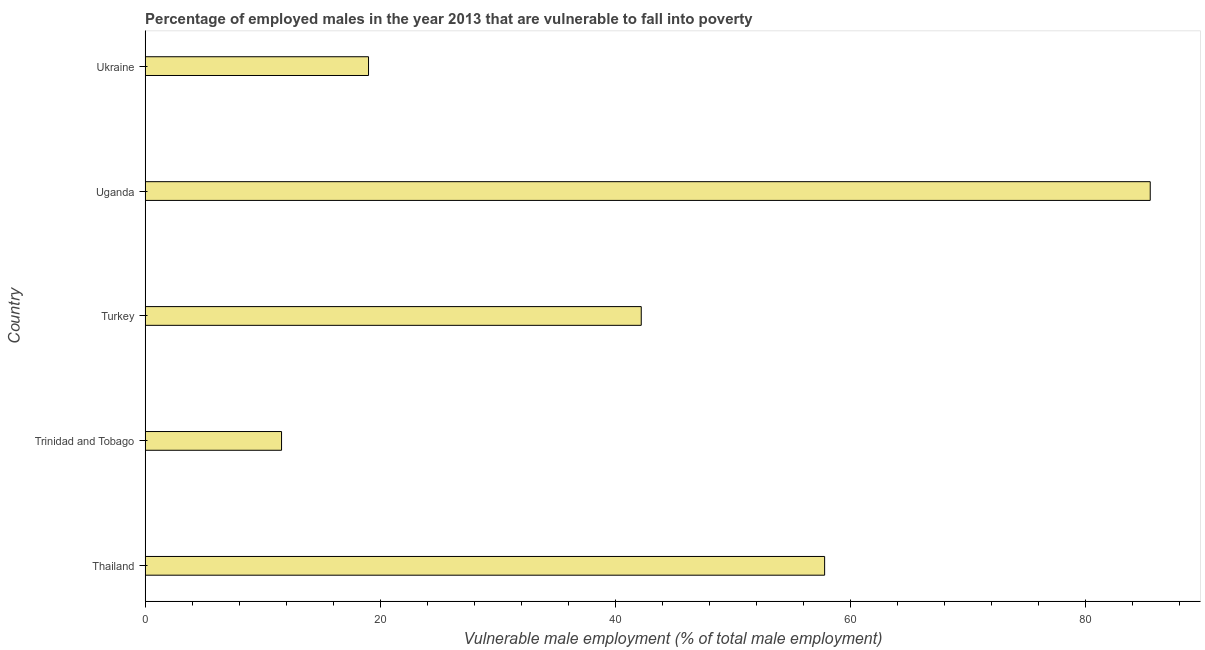Does the graph contain any zero values?
Provide a short and direct response. No. Does the graph contain grids?
Your answer should be compact. No. What is the title of the graph?
Offer a terse response. Percentage of employed males in the year 2013 that are vulnerable to fall into poverty. What is the label or title of the X-axis?
Give a very brief answer. Vulnerable male employment (% of total male employment). What is the percentage of employed males who are vulnerable to fall into poverty in Turkey?
Give a very brief answer. 42.2. Across all countries, what is the maximum percentage of employed males who are vulnerable to fall into poverty?
Offer a very short reply. 85.5. Across all countries, what is the minimum percentage of employed males who are vulnerable to fall into poverty?
Your answer should be compact. 11.6. In which country was the percentage of employed males who are vulnerable to fall into poverty maximum?
Ensure brevity in your answer.  Uganda. In which country was the percentage of employed males who are vulnerable to fall into poverty minimum?
Your response must be concise. Trinidad and Tobago. What is the sum of the percentage of employed males who are vulnerable to fall into poverty?
Keep it short and to the point. 216.1. What is the difference between the percentage of employed males who are vulnerable to fall into poverty in Uganda and Ukraine?
Provide a succinct answer. 66.5. What is the average percentage of employed males who are vulnerable to fall into poverty per country?
Keep it short and to the point. 43.22. What is the median percentage of employed males who are vulnerable to fall into poverty?
Make the answer very short. 42.2. What is the ratio of the percentage of employed males who are vulnerable to fall into poverty in Trinidad and Tobago to that in Ukraine?
Ensure brevity in your answer.  0.61. Is the percentage of employed males who are vulnerable to fall into poverty in Uganda less than that in Ukraine?
Offer a terse response. No. Is the difference between the percentage of employed males who are vulnerable to fall into poverty in Thailand and Trinidad and Tobago greater than the difference between any two countries?
Your answer should be compact. No. What is the difference between the highest and the second highest percentage of employed males who are vulnerable to fall into poverty?
Your answer should be very brief. 27.7. What is the difference between the highest and the lowest percentage of employed males who are vulnerable to fall into poverty?
Make the answer very short. 73.9. How many bars are there?
Make the answer very short. 5. Are all the bars in the graph horizontal?
Offer a terse response. Yes. What is the Vulnerable male employment (% of total male employment) of Thailand?
Your answer should be very brief. 57.8. What is the Vulnerable male employment (% of total male employment) in Trinidad and Tobago?
Make the answer very short. 11.6. What is the Vulnerable male employment (% of total male employment) in Turkey?
Your answer should be very brief. 42.2. What is the Vulnerable male employment (% of total male employment) of Uganda?
Make the answer very short. 85.5. What is the Vulnerable male employment (% of total male employment) of Ukraine?
Offer a terse response. 19. What is the difference between the Vulnerable male employment (% of total male employment) in Thailand and Trinidad and Tobago?
Ensure brevity in your answer.  46.2. What is the difference between the Vulnerable male employment (% of total male employment) in Thailand and Uganda?
Give a very brief answer. -27.7. What is the difference between the Vulnerable male employment (% of total male employment) in Thailand and Ukraine?
Your answer should be compact. 38.8. What is the difference between the Vulnerable male employment (% of total male employment) in Trinidad and Tobago and Turkey?
Provide a short and direct response. -30.6. What is the difference between the Vulnerable male employment (% of total male employment) in Trinidad and Tobago and Uganda?
Keep it short and to the point. -73.9. What is the difference between the Vulnerable male employment (% of total male employment) in Turkey and Uganda?
Ensure brevity in your answer.  -43.3. What is the difference between the Vulnerable male employment (% of total male employment) in Turkey and Ukraine?
Your response must be concise. 23.2. What is the difference between the Vulnerable male employment (% of total male employment) in Uganda and Ukraine?
Give a very brief answer. 66.5. What is the ratio of the Vulnerable male employment (% of total male employment) in Thailand to that in Trinidad and Tobago?
Provide a short and direct response. 4.98. What is the ratio of the Vulnerable male employment (% of total male employment) in Thailand to that in Turkey?
Your response must be concise. 1.37. What is the ratio of the Vulnerable male employment (% of total male employment) in Thailand to that in Uganda?
Offer a very short reply. 0.68. What is the ratio of the Vulnerable male employment (% of total male employment) in Thailand to that in Ukraine?
Offer a very short reply. 3.04. What is the ratio of the Vulnerable male employment (% of total male employment) in Trinidad and Tobago to that in Turkey?
Provide a succinct answer. 0.28. What is the ratio of the Vulnerable male employment (% of total male employment) in Trinidad and Tobago to that in Uganda?
Offer a terse response. 0.14. What is the ratio of the Vulnerable male employment (% of total male employment) in Trinidad and Tobago to that in Ukraine?
Give a very brief answer. 0.61. What is the ratio of the Vulnerable male employment (% of total male employment) in Turkey to that in Uganda?
Ensure brevity in your answer.  0.49. What is the ratio of the Vulnerable male employment (% of total male employment) in Turkey to that in Ukraine?
Provide a succinct answer. 2.22. What is the ratio of the Vulnerable male employment (% of total male employment) in Uganda to that in Ukraine?
Your answer should be very brief. 4.5. 